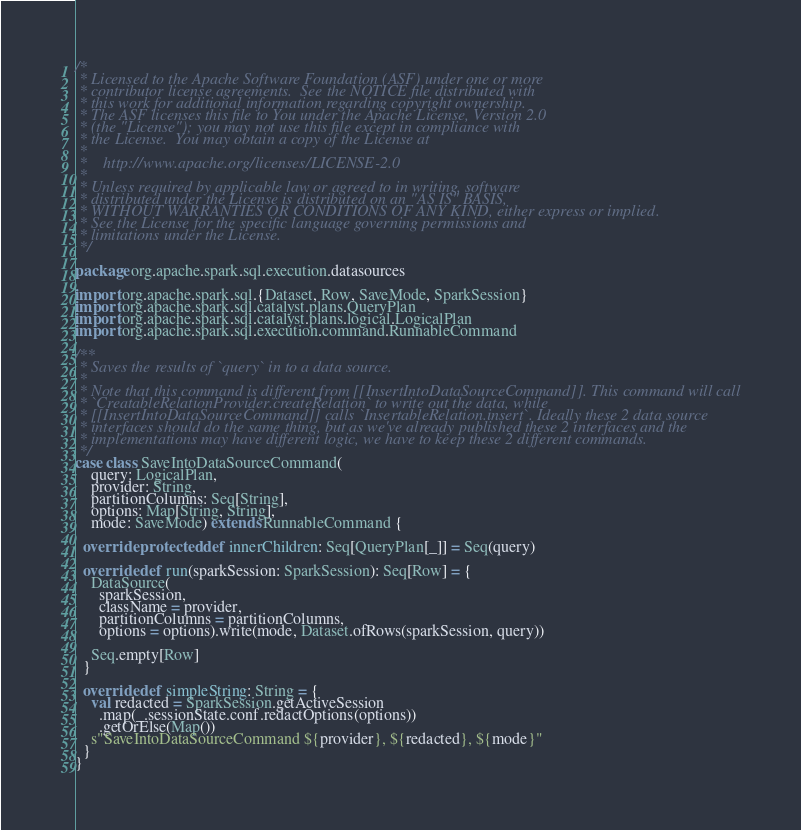<code> <loc_0><loc_0><loc_500><loc_500><_Scala_>/*
 * Licensed to the Apache Software Foundation (ASF) under one or more
 * contributor license agreements.  See the NOTICE file distributed with
 * this work for additional information regarding copyright ownership.
 * The ASF licenses this file to You under the Apache License, Version 2.0
 * (the "License"); you may not use this file except in compliance with
 * the License.  You may obtain a copy of the License at
 *
 *    http://www.apache.org/licenses/LICENSE-2.0
 *
 * Unless required by applicable law or agreed to in writing, software
 * distributed under the License is distributed on an "AS IS" BASIS,
 * WITHOUT WARRANTIES OR CONDITIONS OF ANY KIND, either express or implied.
 * See the License for the specific language governing permissions and
 * limitations under the License.
 */

package org.apache.spark.sql.execution.datasources

import org.apache.spark.sql.{Dataset, Row, SaveMode, SparkSession}
import org.apache.spark.sql.catalyst.plans.QueryPlan
import org.apache.spark.sql.catalyst.plans.logical.LogicalPlan
import org.apache.spark.sql.execution.command.RunnableCommand

/**
 * Saves the results of `query` in to a data source.
 *
 * Note that this command is different from [[InsertIntoDataSourceCommand]]. This command will call
 * `CreatableRelationProvider.createRelation` to write out the data, while
 * [[InsertIntoDataSourceCommand]] calls `InsertableRelation.insert`. Ideally these 2 data source
 * interfaces should do the same thing, but as we've already published these 2 interfaces and the
 * implementations may have different logic, we have to keep these 2 different commands.
 */
case class SaveIntoDataSourceCommand(
    query: LogicalPlan,
    provider: String,
    partitionColumns: Seq[String],
    options: Map[String, String],
    mode: SaveMode) extends RunnableCommand {

  override protected def innerChildren: Seq[QueryPlan[_]] = Seq(query)

  override def run(sparkSession: SparkSession): Seq[Row] = {
    DataSource(
      sparkSession,
      className = provider,
      partitionColumns = partitionColumns,
      options = options).write(mode, Dataset.ofRows(sparkSession, query))

    Seq.empty[Row]
  }

  override def simpleString: String = {
    val redacted = SparkSession.getActiveSession
      .map(_.sessionState.conf.redactOptions(options))
      .getOrElse(Map())
    s"SaveIntoDataSourceCommand ${provider}, ${redacted}, ${mode}"
  }
}
</code> 